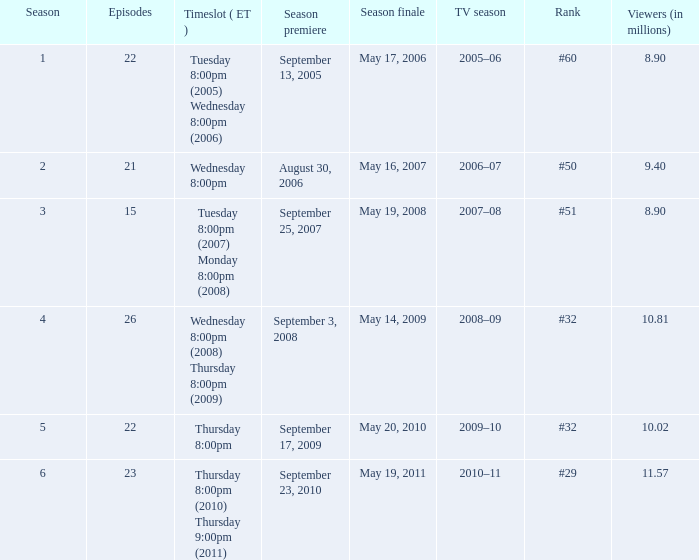When did the season finale reached an audience of 10.02 million viewers? May 20, 2010. 